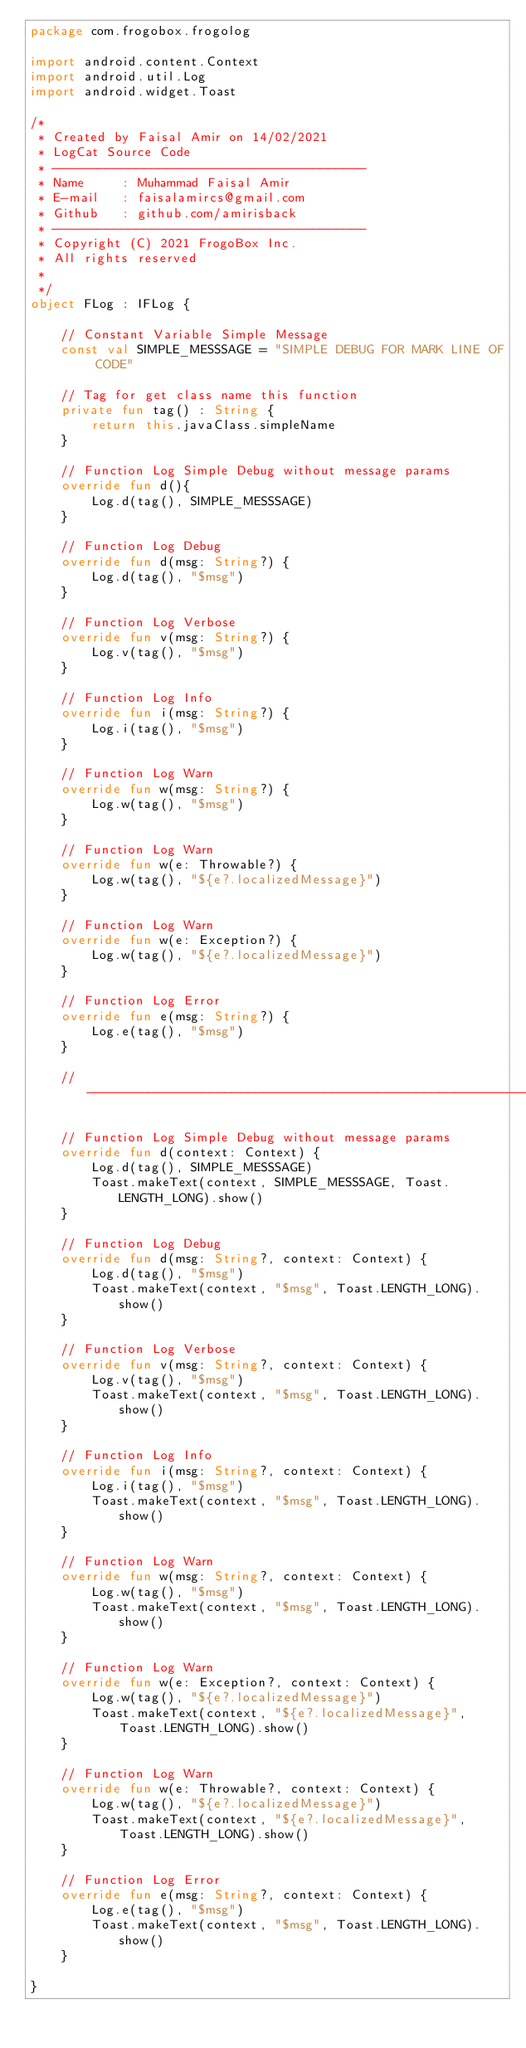<code> <loc_0><loc_0><loc_500><loc_500><_Kotlin_>package com.frogobox.frogolog

import android.content.Context
import android.util.Log
import android.widget.Toast

/*
 * Created by Faisal Amir on 14/02/2021
 * LogCat Source Code
 * -----------------------------------------
 * Name     : Muhammad Faisal Amir
 * E-mail   : faisalamircs@gmail.com
 * Github   : github.com/amirisback
 * -----------------------------------------
 * Copyright (C) 2021 FrogoBox Inc.      
 * All rights reserved
 *
 */
object FLog : IFLog {

    // Constant Variable Simple Message
    const val SIMPLE_MESSSAGE = "SIMPLE DEBUG FOR MARK LINE OF CODE"

    // Tag for get class name this function
    private fun tag() : String {
        return this.javaClass.simpleName
    }
    
    // Function Log Simple Debug without message params
    override fun d(){
        Log.d(tag(), SIMPLE_MESSSAGE)
    }

    // Function Log Debug
    override fun d(msg: String?) {
        Log.d(tag(), "$msg")
    }

    // Function Log Verbose
    override fun v(msg: String?) {
        Log.v(tag(), "$msg")
    }

    // Function Log Info
    override fun i(msg: String?) {
        Log.i(tag(), "$msg")
    }

    // Function Log Warn
    override fun w(msg: String?) {
        Log.w(tag(), "$msg")
    }

    // Function Log Warn
    override fun w(e: Throwable?) {
        Log.w(tag(), "${e?.localizedMessage}")
    }

    // Function Log Warn
    override fun w(e: Exception?) {
        Log.w(tag(), "${e?.localizedMessage}")
    }

    // Function Log Error
    override fun e(msg: String?) {
        Log.e(tag(), "$msg")
    }

    // ---------------------------------------------------------------------------------------------

    // Function Log Simple Debug without message params
    override fun d(context: Context) {
        Log.d(tag(), SIMPLE_MESSSAGE)
        Toast.makeText(context, SIMPLE_MESSSAGE, Toast.LENGTH_LONG).show()
    }

    // Function Log Debug
    override fun d(msg: String?, context: Context) {
        Log.d(tag(), "$msg")
        Toast.makeText(context, "$msg", Toast.LENGTH_LONG).show()
    }

    // Function Log Verbose
    override fun v(msg: String?, context: Context) {
        Log.v(tag(), "$msg")
        Toast.makeText(context, "$msg", Toast.LENGTH_LONG).show()
    }

    // Function Log Info
    override fun i(msg: String?, context: Context) {
        Log.i(tag(), "$msg")
        Toast.makeText(context, "$msg", Toast.LENGTH_LONG).show()
    }

    // Function Log Warn
    override fun w(msg: String?, context: Context) {
        Log.w(tag(), "$msg")
        Toast.makeText(context, "$msg", Toast.LENGTH_LONG).show()
    }

    // Function Log Warn
    override fun w(e: Exception?, context: Context) {
        Log.w(tag(), "${e?.localizedMessage}")
        Toast.makeText(context, "${e?.localizedMessage}", Toast.LENGTH_LONG).show()
    }

    // Function Log Warn
    override fun w(e: Throwable?, context: Context) {
        Log.w(tag(), "${e?.localizedMessage}")
        Toast.makeText(context, "${e?.localizedMessage}", Toast.LENGTH_LONG).show()
    }

    // Function Log Error
    override fun e(msg: String?, context: Context) {
        Log.e(tag(), "$msg")
        Toast.makeText(context, "$msg", Toast.LENGTH_LONG).show()
    }
    
}</code> 